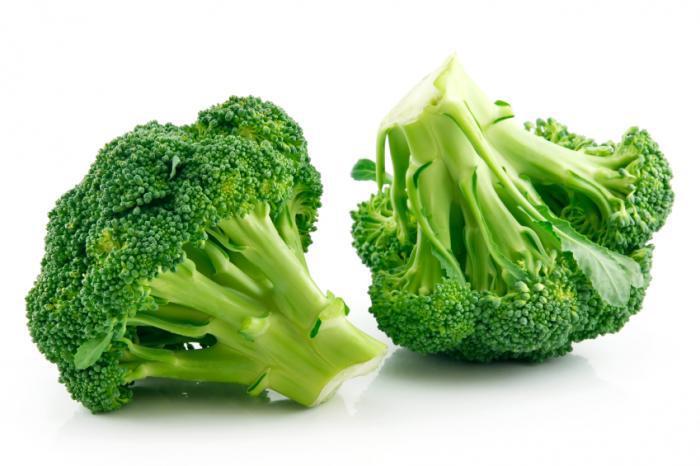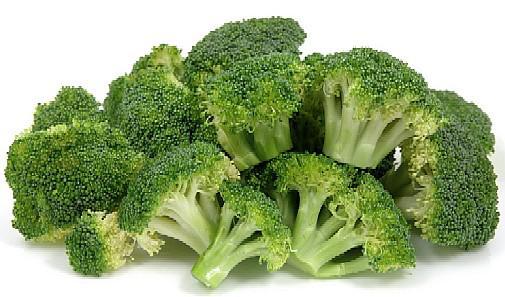The first image is the image on the left, the second image is the image on the right. For the images shown, is this caption "Brocolli sits in a white bowl in the image on the right." true? Answer yes or no. No. The first image is the image on the left, the second image is the image on the right. For the images shown, is this caption "An image includes a white bowl that contains multiple broccoli florets." true? Answer yes or no. No. 